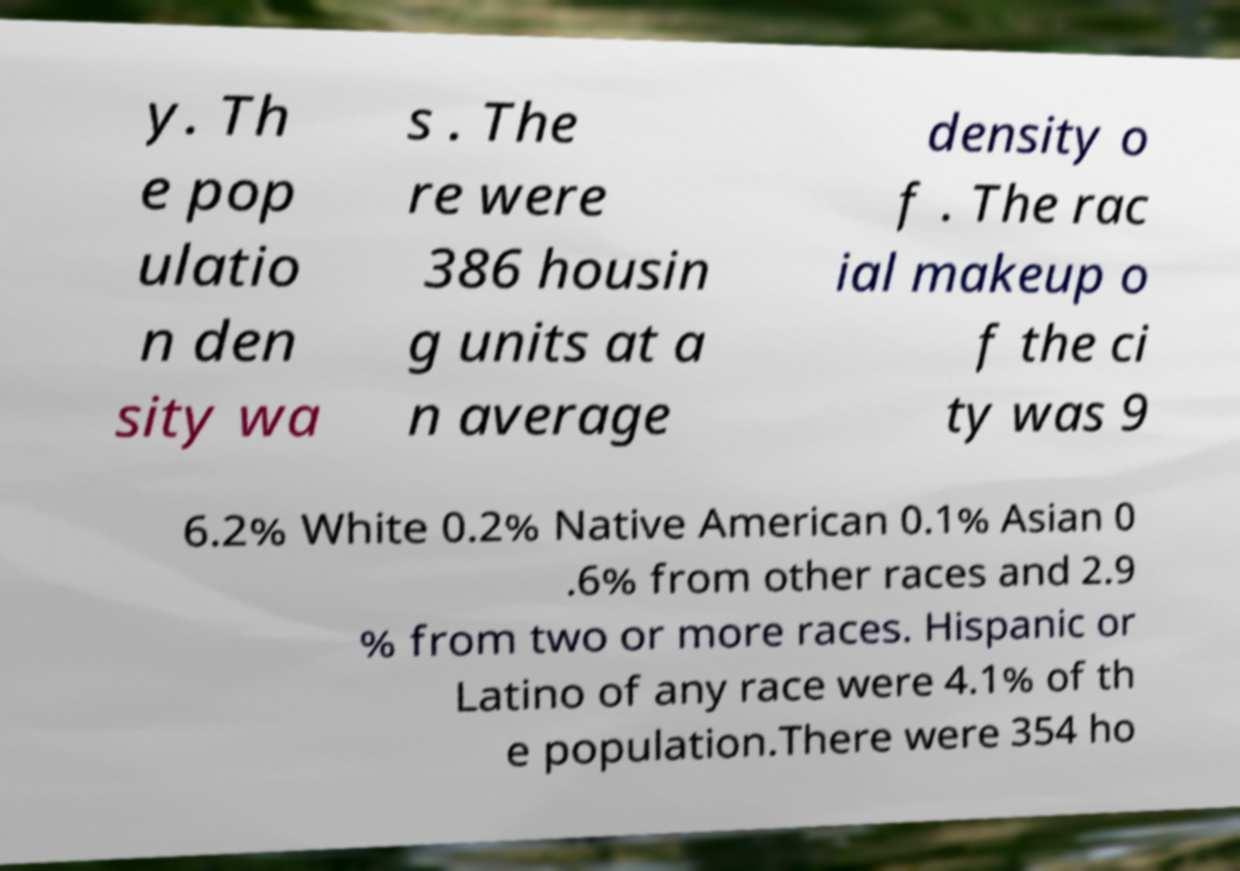Can you read and provide the text displayed in the image?This photo seems to have some interesting text. Can you extract and type it out for me? y. Th e pop ulatio n den sity wa s . The re were 386 housin g units at a n average density o f . The rac ial makeup o f the ci ty was 9 6.2% White 0.2% Native American 0.1% Asian 0 .6% from other races and 2.9 % from two or more races. Hispanic or Latino of any race were 4.1% of th e population.There were 354 ho 